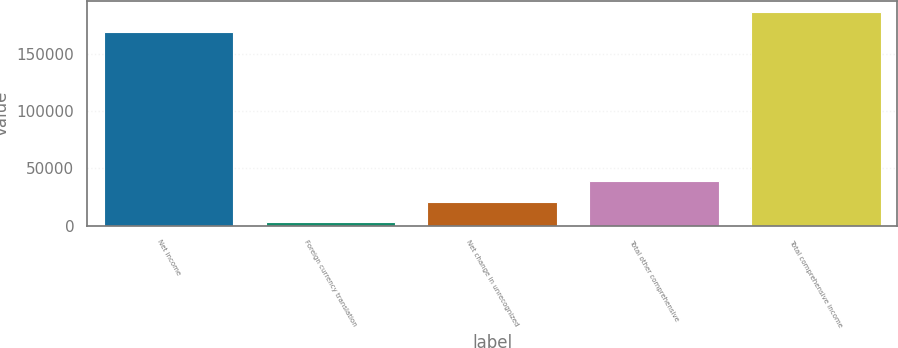Convert chart to OTSL. <chart><loc_0><loc_0><loc_500><loc_500><bar_chart><fcel>Net income<fcel>Foreign currency translation<fcel>Net change in unrecognized<fcel>Total other comprehensive<fcel>Total comprehensive income<nl><fcel>169071<fcel>3078<fcel>20854.8<fcel>38631.6<fcel>186848<nl></chart> 